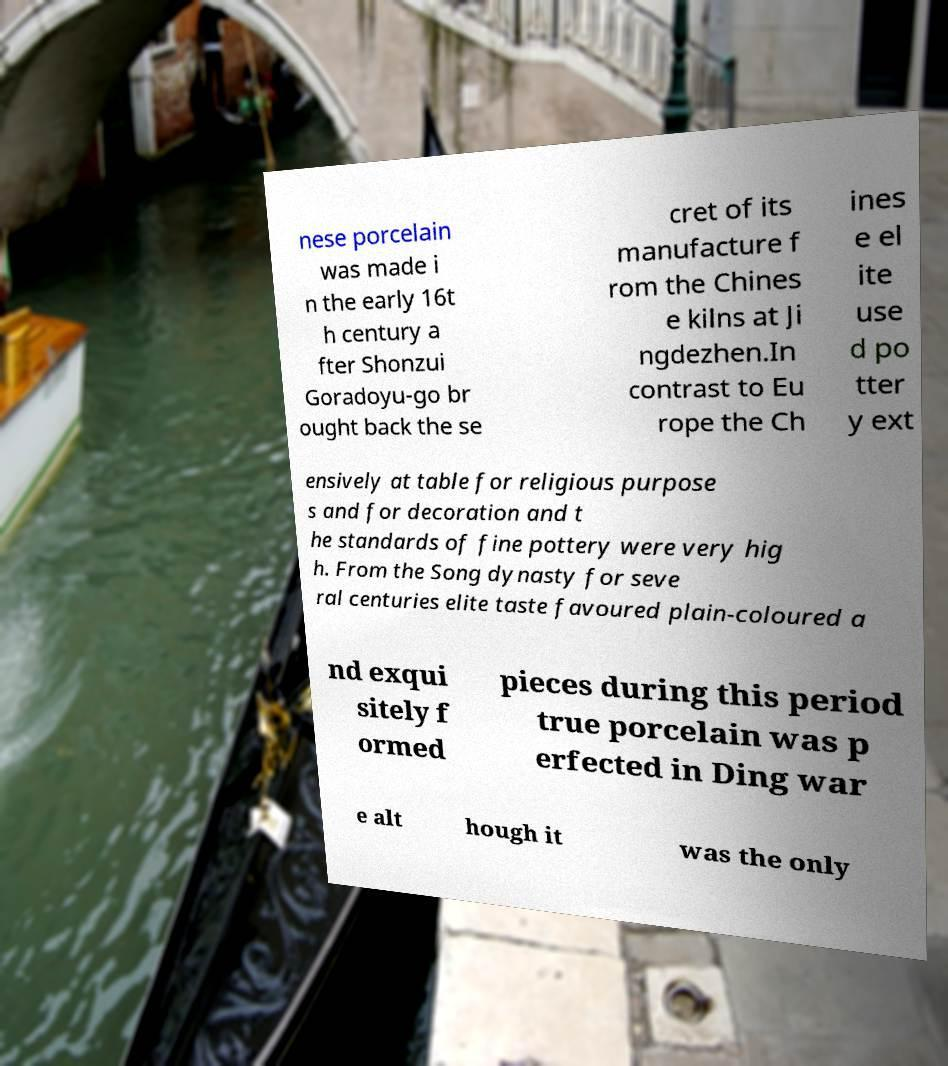Can you read and provide the text displayed in the image?This photo seems to have some interesting text. Can you extract and type it out for me? nese porcelain was made i n the early 16t h century a fter Shonzui Goradoyu-go br ought back the se cret of its manufacture f rom the Chines e kilns at Ji ngdezhen.In contrast to Eu rope the Ch ines e el ite use d po tter y ext ensively at table for religious purpose s and for decoration and t he standards of fine pottery were very hig h. From the Song dynasty for seve ral centuries elite taste favoured plain-coloured a nd exqui sitely f ormed pieces during this period true porcelain was p erfected in Ding war e alt hough it was the only 